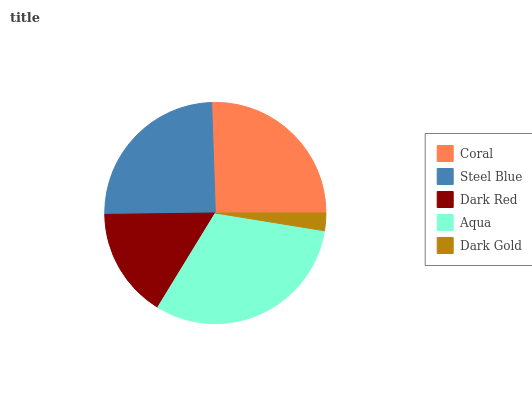Is Dark Gold the minimum?
Answer yes or no. Yes. Is Aqua the maximum?
Answer yes or no. Yes. Is Steel Blue the minimum?
Answer yes or no. No. Is Steel Blue the maximum?
Answer yes or no. No. Is Coral greater than Steel Blue?
Answer yes or no. Yes. Is Steel Blue less than Coral?
Answer yes or no. Yes. Is Steel Blue greater than Coral?
Answer yes or no. No. Is Coral less than Steel Blue?
Answer yes or no. No. Is Steel Blue the high median?
Answer yes or no. Yes. Is Steel Blue the low median?
Answer yes or no. Yes. Is Dark Red the high median?
Answer yes or no. No. Is Coral the low median?
Answer yes or no. No. 